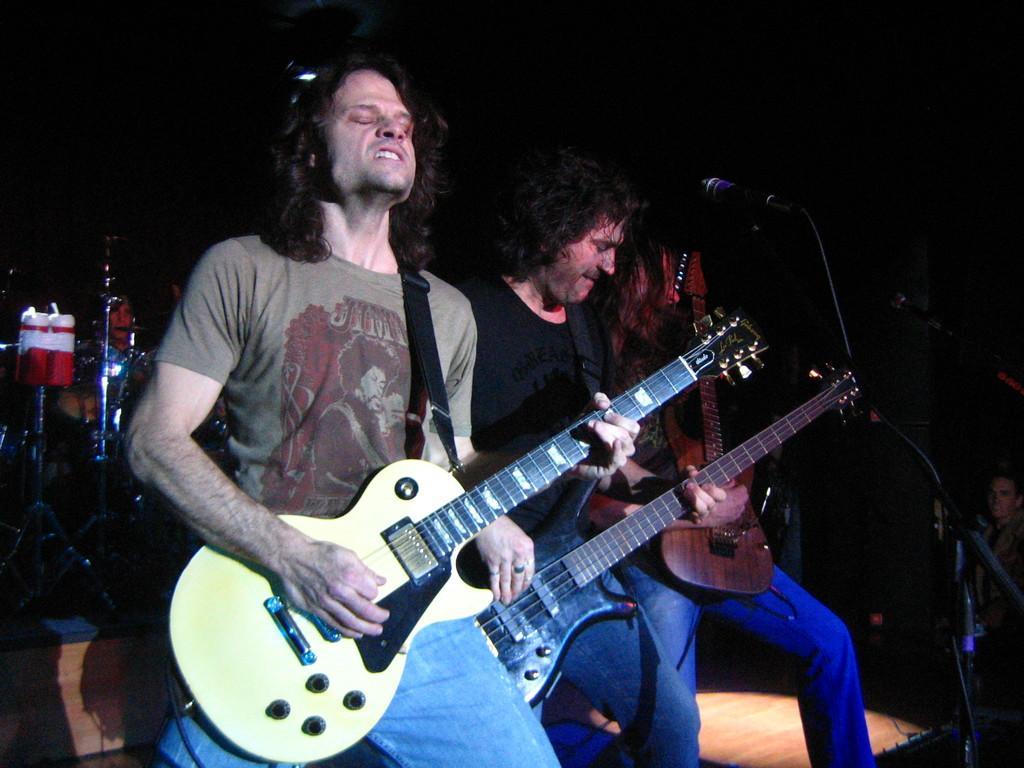Please provide a concise description of this image. In this image, we can see three men standing, they are holding guitars, we can see a microphone, there is a dark background. 